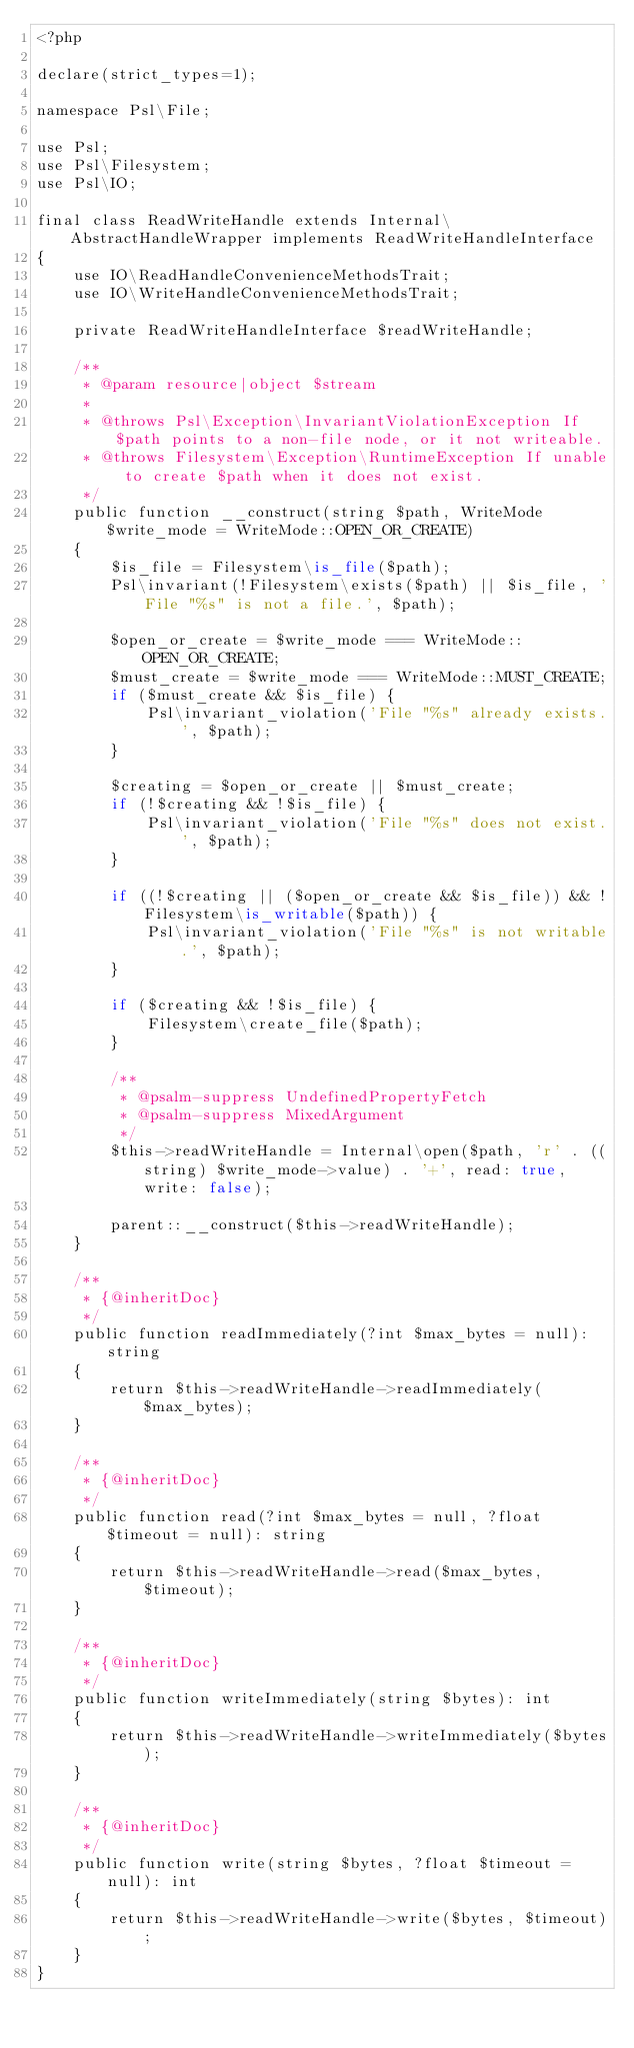<code> <loc_0><loc_0><loc_500><loc_500><_PHP_><?php

declare(strict_types=1);

namespace Psl\File;

use Psl;
use Psl\Filesystem;
use Psl\IO;

final class ReadWriteHandle extends Internal\AbstractHandleWrapper implements ReadWriteHandleInterface
{
    use IO\ReadHandleConvenienceMethodsTrait;
    use IO\WriteHandleConvenienceMethodsTrait;

    private ReadWriteHandleInterface $readWriteHandle;

    /**
     * @param resource|object $stream
     *
     * @throws Psl\Exception\InvariantViolationException If $path points to a non-file node, or it not writeable.
     * @throws Filesystem\Exception\RuntimeException If unable to create $path when it does not exist.
     */
    public function __construct(string $path, WriteMode $write_mode = WriteMode::OPEN_OR_CREATE)
    {
        $is_file = Filesystem\is_file($path);
        Psl\invariant(!Filesystem\exists($path) || $is_file, 'File "%s" is not a file.', $path);

        $open_or_create = $write_mode === WriteMode::OPEN_OR_CREATE;
        $must_create = $write_mode === WriteMode::MUST_CREATE;
        if ($must_create && $is_file) {
            Psl\invariant_violation('File "%s" already exists.', $path);
        }

        $creating = $open_or_create || $must_create;
        if (!$creating && !$is_file) {
            Psl\invariant_violation('File "%s" does not exist.', $path);
        }

        if ((!$creating || ($open_or_create && $is_file)) && !Filesystem\is_writable($path)) {
            Psl\invariant_violation('File "%s" is not writable.', $path);
        }

        if ($creating && !$is_file) {
            Filesystem\create_file($path);
        }

        /**
         * @psalm-suppress UndefinedPropertyFetch
         * @psalm-suppress MixedArgument
         */
        $this->readWriteHandle = Internal\open($path, 'r' . ((string) $write_mode->value) . '+', read: true, write: false);

        parent::__construct($this->readWriteHandle);
    }

    /**
     * {@inheritDoc}
     */
    public function readImmediately(?int $max_bytes = null): string
    {
        return $this->readWriteHandle->readImmediately($max_bytes);
    }

    /**
     * {@inheritDoc}
     */
    public function read(?int $max_bytes = null, ?float $timeout = null): string
    {
        return $this->readWriteHandle->read($max_bytes, $timeout);
    }

    /**
     * {@inheritDoc}
     */
    public function writeImmediately(string $bytes): int
    {
        return $this->readWriteHandle->writeImmediately($bytes);
    }

    /**
     * {@inheritDoc}
     */
    public function write(string $bytes, ?float $timeout = null): int
    {
        return $this->readWriteHandle->write($bytes, $timeout);
    }
}
</code> 